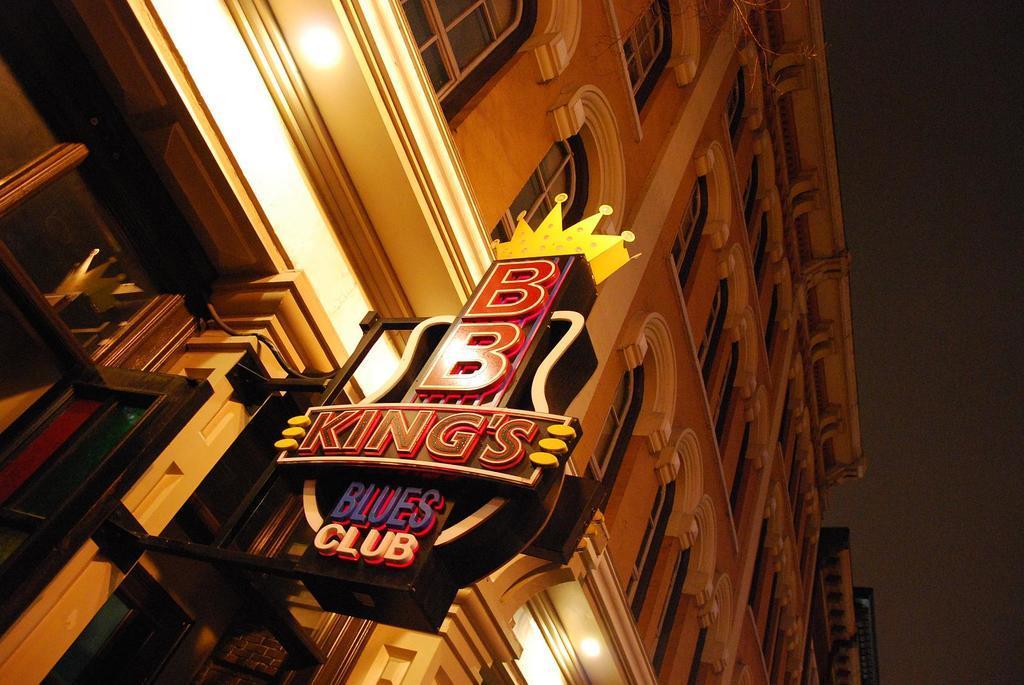How would you summarize this image in a sentence or two? In this image I can see building, windows, board, lights and sky. 